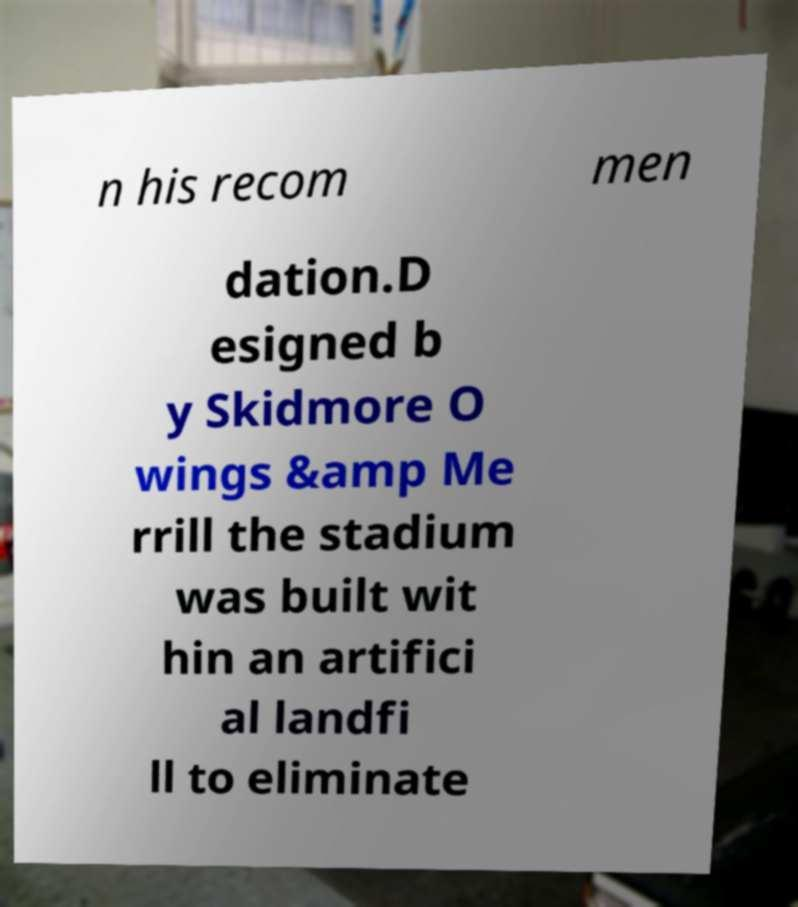Please read and relay the text visible in this image. What does it say? n his recom men dation.D esigned b y Skidmore O wings &amp Me rrill the stadium was built wit hin an artifici al landfi ll to eliminate 